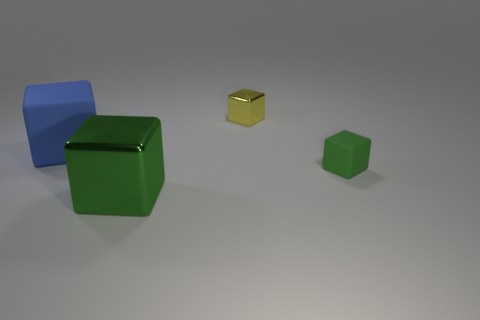There is another cube that is the same color as the large shiny block; what material is it?
Your response must be concise. Rubber. Do the small metallic block and the large shiny block have the same color?
Your response must be concise. No. The object that is behind the small green cube and in front of the tiny yellow thing is what color?
Provide a succinct answer. Blue. What number of objects are either rubber objects that are to the left of the yellow shiny cube or small yellow blocks?
Ensure brevity in your answer.  2. What color is the other large object that is the same shape as the big green metallic thing?
Your answer should be compact. Blue. Is the shape of the small yellow thing the same as the metallic thing that is left of the tiny yellow metal block?
Provide a short and direct response. Yes. What number of objects are either cubes in front of the small matte block or matte objects that are to the left of the tiny green matte object?
Offer a terse response. 2. Is the number of blue objects in front of the big blue matte cube less than the number of matte blocks?
Provide a short and direct response. Yes. Are the tiny yellow block and the large cube that is in front of the tiny matte block made of the same material?
Offer a terse response. Yes. What is the material of the tiny yellow cube?
Offer a very short reply. Metal. 